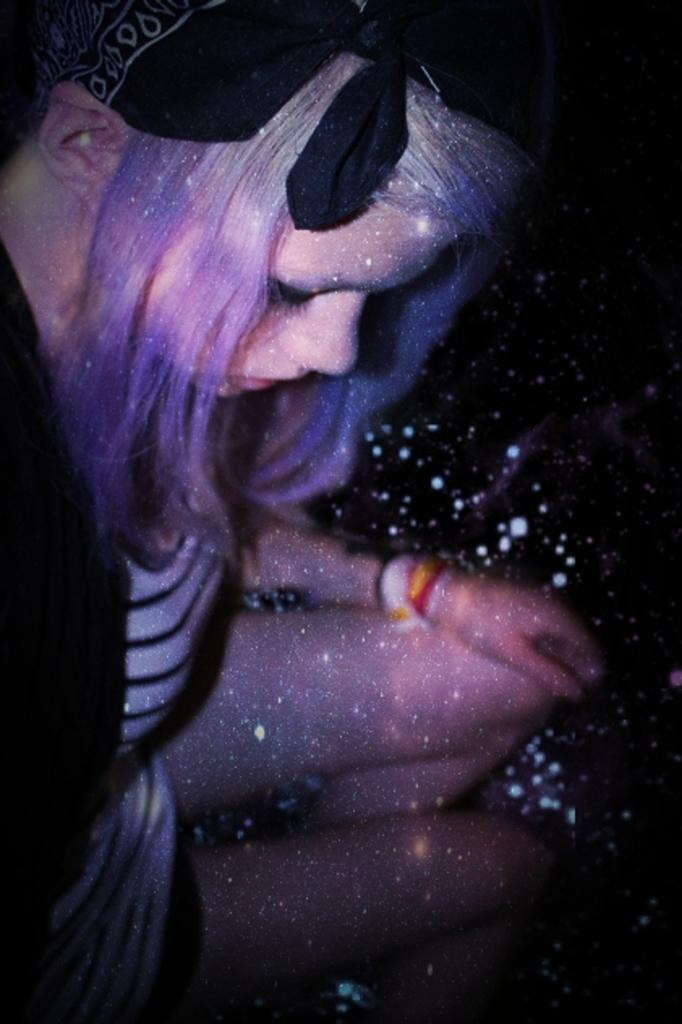What is the person in the image doing? The person is sitting in the image. What is the person wearing? The person is wearing a white and black color dress. How would you describe the color scheme of the image? The image contains different shades. What color is the background of the image? The background of the image is black. Is there a gun visible in the image? No, there is no gun present in the image. Can you see a plane flying in the background of the image? No, there is no plane visible in the image. 